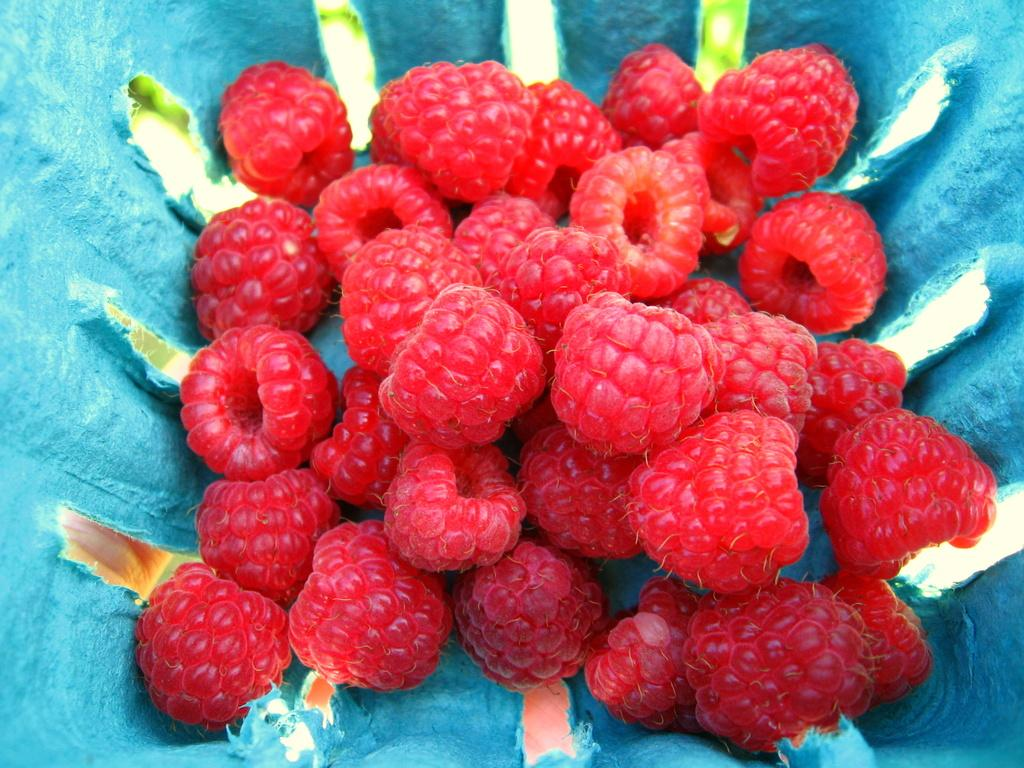What type of fruit is present in the image? There are raspberries in the image. How are the raspberries contained or displayed? The raspberries are in a cloth. How many trucks are carrying raspberries on their journey in the image? There are no trucks or journeys present in the image; it only features raspberries in a cloth. Is there a beggar asking for raspberries in the image? There is no beggar present in the image; it only features raspberries in a cloth. 